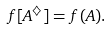<formula> <loc_0><loc_0><loc_500><loc_500>f [ A ^ { \diamondsuit } ] = f ( A ) .</formula> 